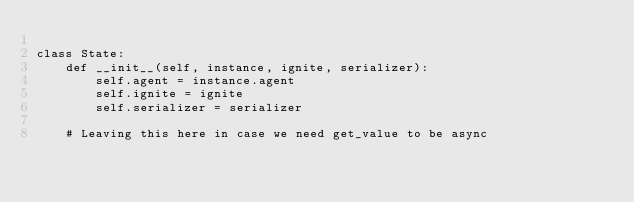Convert code to text. <code><loc_0><loc_0><loc_500><loc_500><_Python_>
class State:
    def __init__(self, instance, ignite, serializer):
        self.agent = instance.agent
        self.ignite = ignite
        self.serializer = serializer

    # Leaving this here in case we need get_value to be async</code> 